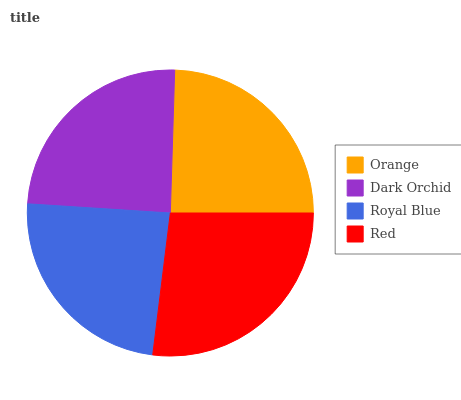Is Royal Blue the minimum?
Answer yes or no. Yes. Is Red the maximum?
Answer yes or no. Yes. Is Dark Orchid the minimum?
Answer yes or no. No. Is Dark Orchid the maximum?
Answer yes or no. No. Is Orange greater than Dark Orchid?
Answer yes or no. Yes. Is Dark Orchid less than Orange?
Answer yes or no. Yes. Is Dark Orchid greater than Orange?
Answer yes or no. No. Is Orange less than Dark Orchid?
Answer yes or no. No. Is Orange the high median?
Answer yes or no. Yes. Is Dark Orchid the low median?
Answer yes or no. Yes. Is Royal Blue the high median?
Answer yes or no. No. Is Red the low median?
Answer yes or no. No. 